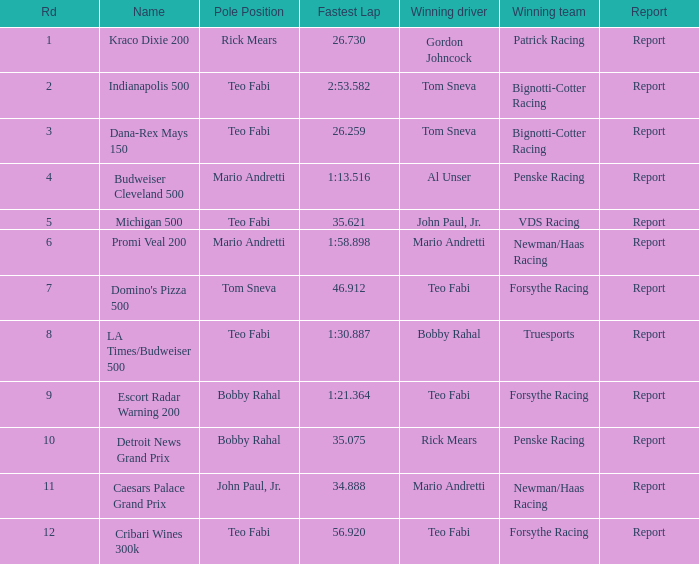Which Rd took place at the Indianapolis 500? 2.0. 